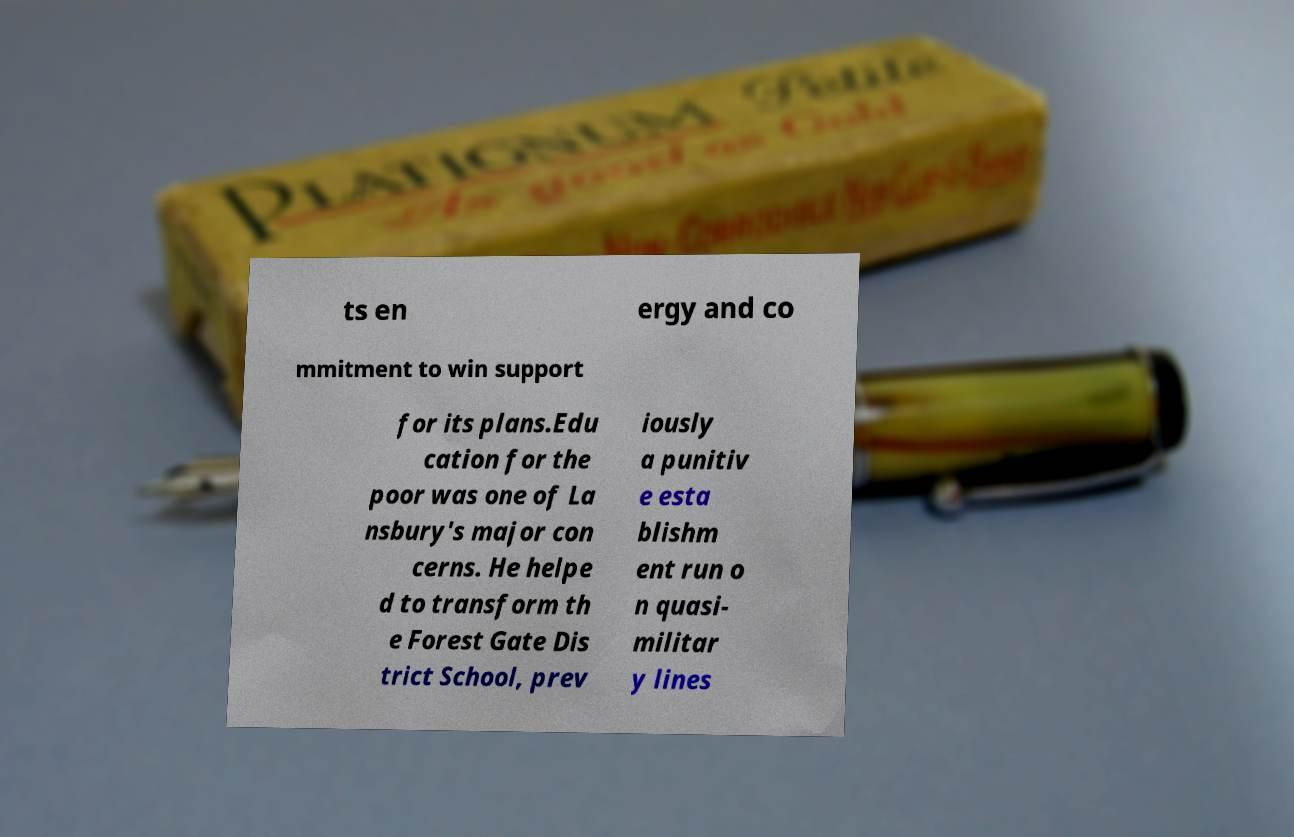Could you extract and type out the text from this image? ts en ergy and co mmitment to win support for its plans.Edu cation for the poor was one of La nsbury's major con cerns. He helpe d to transform th e Forest Gate Dis trict School, prev iously a punitiv e esta blishm ent run o n quasi- militar y lines 